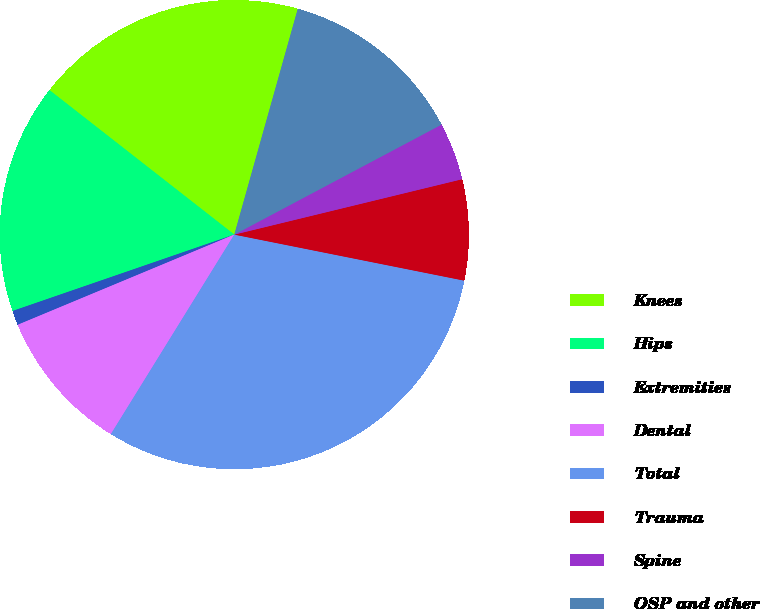Convert chart. <chart><loc_0><loc_0><loc_500><loc_500><pie_chart><fcel>Knees<fcel>Hips<fcel>Extremities<fcel>Dental<fcel>Total<fcel>Trauma<fcel>Spine<fcel>OSP and other<nl><fcel>18.8%<fcel>15.84%<fcel>1.0%<fcel>9.9%<fcel>30.67%<fcel>6.94%<fcel>3.97%<fcel>12.87%<nl></chart> 